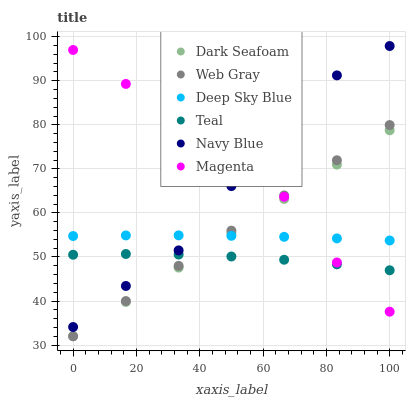Does Teal have the minimum area under the curve?
Answer yes or no. Yes. Does Magenta have the maximum area under the curve?
Answer yes or no. Yes. Does Deep Sky Blue have the minimum area under the curve?
Answer yes or no. No. Does Deep Sky Blue have the maximum area under the curve?
Answer yes or no. No. Is Web Gray the smoothest?
Answer yes or no. Yes. Is Navy Blue the roughest?
Answer yes or no. Yes. Is Deep Sky Blue the smoothest?
Answer yes or no. No. Is Deep Sky Blue the roughest?
Answer yes or no. No. Does Web Gray have the lowest value?
Answer yes or no. Yes. Does Navy Blue have the lowest value?
Answer yes or no. No. Does Navy Blue have the highest value?
Answer yes or no. Yes. Does Deep Sky Blue have the highest value?
Answer yes or no. No. Is Dark Seafoam less than Navy Blue?
Answer yes or no. Yes. Is Navy Blue greater than Web Gray?
Answer yes or no. Yes. Does Dark Seafoam intersect Teal?
Answer yes or no. Yes. Is Dark Seafoam less than Teal?
Answer yes or no. No. Is Dark Seafoam greater than Teal?
Answer yes or no. No. Does Dark Seafoam intersect Navy Blue?
Answer yes or no. No. 